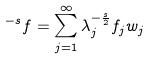<formula> <loc_0><loc_0><loc_500><loc_500>\L ^ { - s } f = \sum _ { j = 1 } ^ { \infty } \lambda _ { j } ^ { - \frac { s } { 2 } } f _ { j } w _ { j }</formula> 